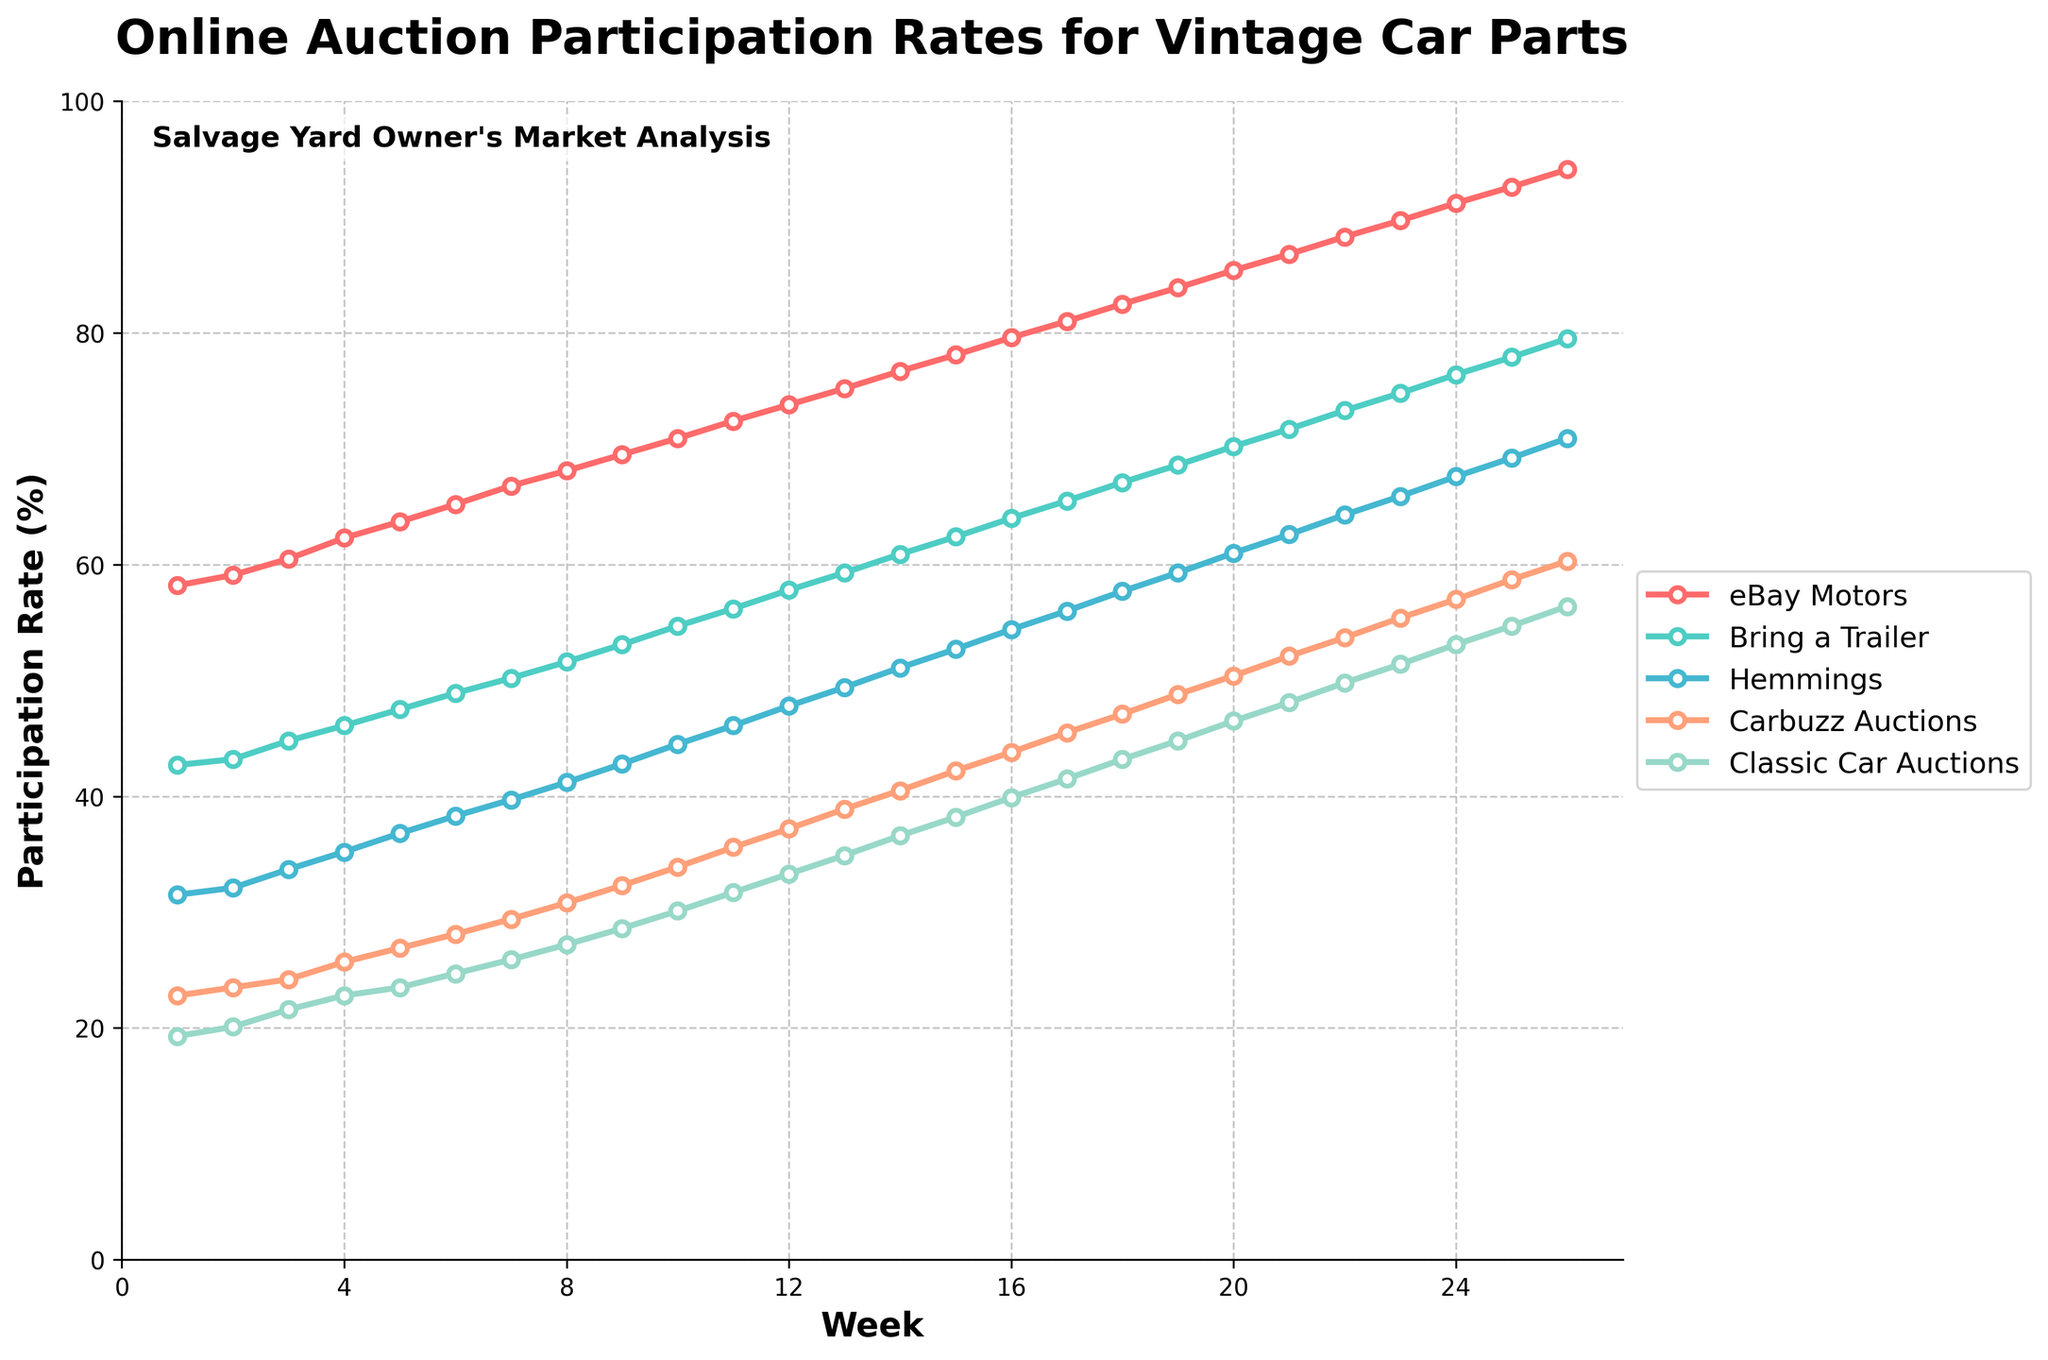1. What is the participation rate of eBay Motors in Week 26? Locate Week 26 on the x-axis and trace upwards to the eBay Motors line, which is the first and red line. Note the y-axis value where the line intersects with Week 26.
Answer: 94.1 2. Which platform has the highest participation rate in Week 15? Find Week 15 on the x-axis, then identify which line is highest at this point. The red line for eBay Motors is at the top.
Answer: eBay Motors 3. How much did the participation rate for Bring a Trailer increase from Week 10 to Week 20? Locate Week 10 and Week 20 for Bring a Trailer on the chart. Note the y-values (54.7 for Week 10 and 70.2 for Week 20), and calculate the difference: 70.2 - 54.7.
Answer: 15.5 4. What is the average participation rate for Classic Car Auctions over the first 10 weeks? Sum the participation rates of Classic Car Auctions for the first 10 weeks (19.3 + 20.1 + 21.6 + 22.8 + 23.5 + 24.7 + 25.9 + 27.2 + 28.6 + 30.1 = 243.8) and divide by 10.
Answer: 24.38 5. Which platform shows the fastest growth in participation rates over the 26 weeks? Compare the slope or steepness of each line from Week 1 to Week 26. The steepest line typically indicates the fastest growth, which is the red line for eBay Motors.
Answer: eBay Motors 6. By how much did the participation rates for Hemmings change from Week 5 to Week 15? Note the values of Hemmings for Week 5 and Week 15 (36.8 and 52.7 respectively), then find the difference: 52.7 - 36.8.
Answer: 15.9 7. During which week did Carbuzz Auctions first surpass 30% participation rate? Identify the point where the green line of Carbuzz Auctions crosses the 30% mark on the y-axis. This occurs around Week 8.
Answer: Week 8 8. What is the participation rate difference between the highest and lowest platforms in Week 25? Note the participation rates for all platforms in Week 25 (92.6, 77.9, 69.2, 58.7, 54.7), then find the difference between the highest (eBay Motors) and lowest (Classic Car Auctions): 92.6 - 54.7.
Answer: 37.9 9. Which two platforms had the closest participation rates in Week 20? Compare the y-values of platforms in Week 20 and find the smallest difference. Hemmings (61.0) and Carbuzz Auctions (50.4) show significant gaps with Classic Car Auctions (46.5) being the closest. However, Hemmings and Bring a Trailer values (61.0 and 70.2) are closest, making the comparative difference, Bring a trailer and Hemmings are the nearest.
Answer: Bring a Trailer and Hemmings 